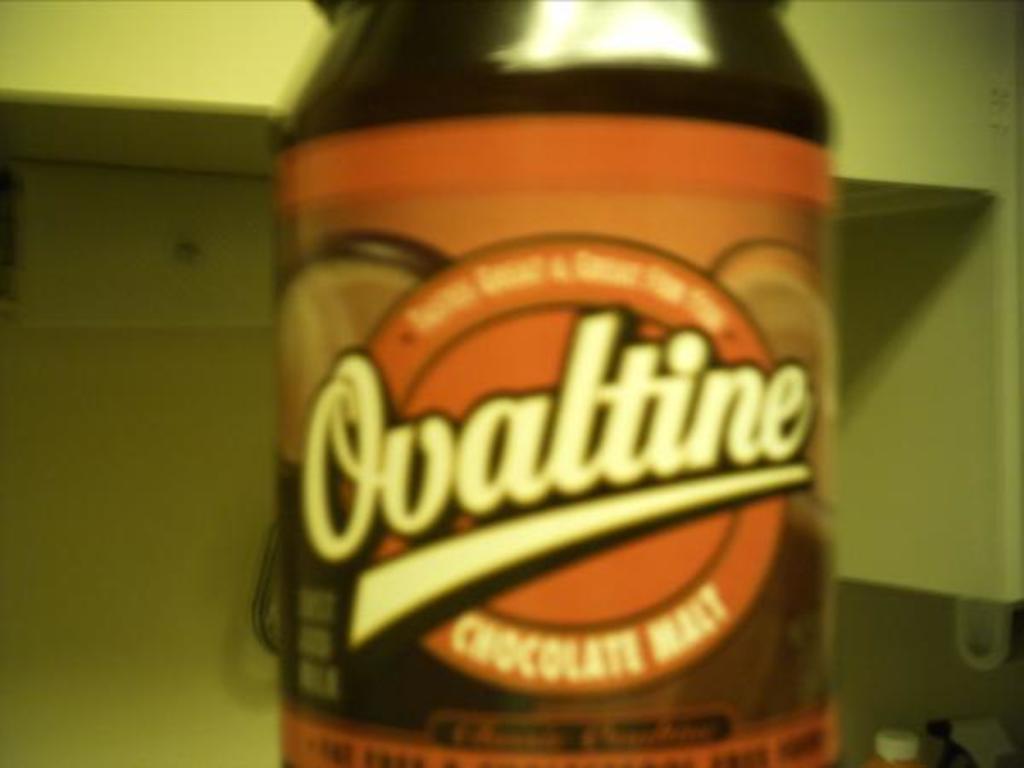What brand of chocolate drink mix is this?
Ensure brevity in your answer.  Ovaltine. 